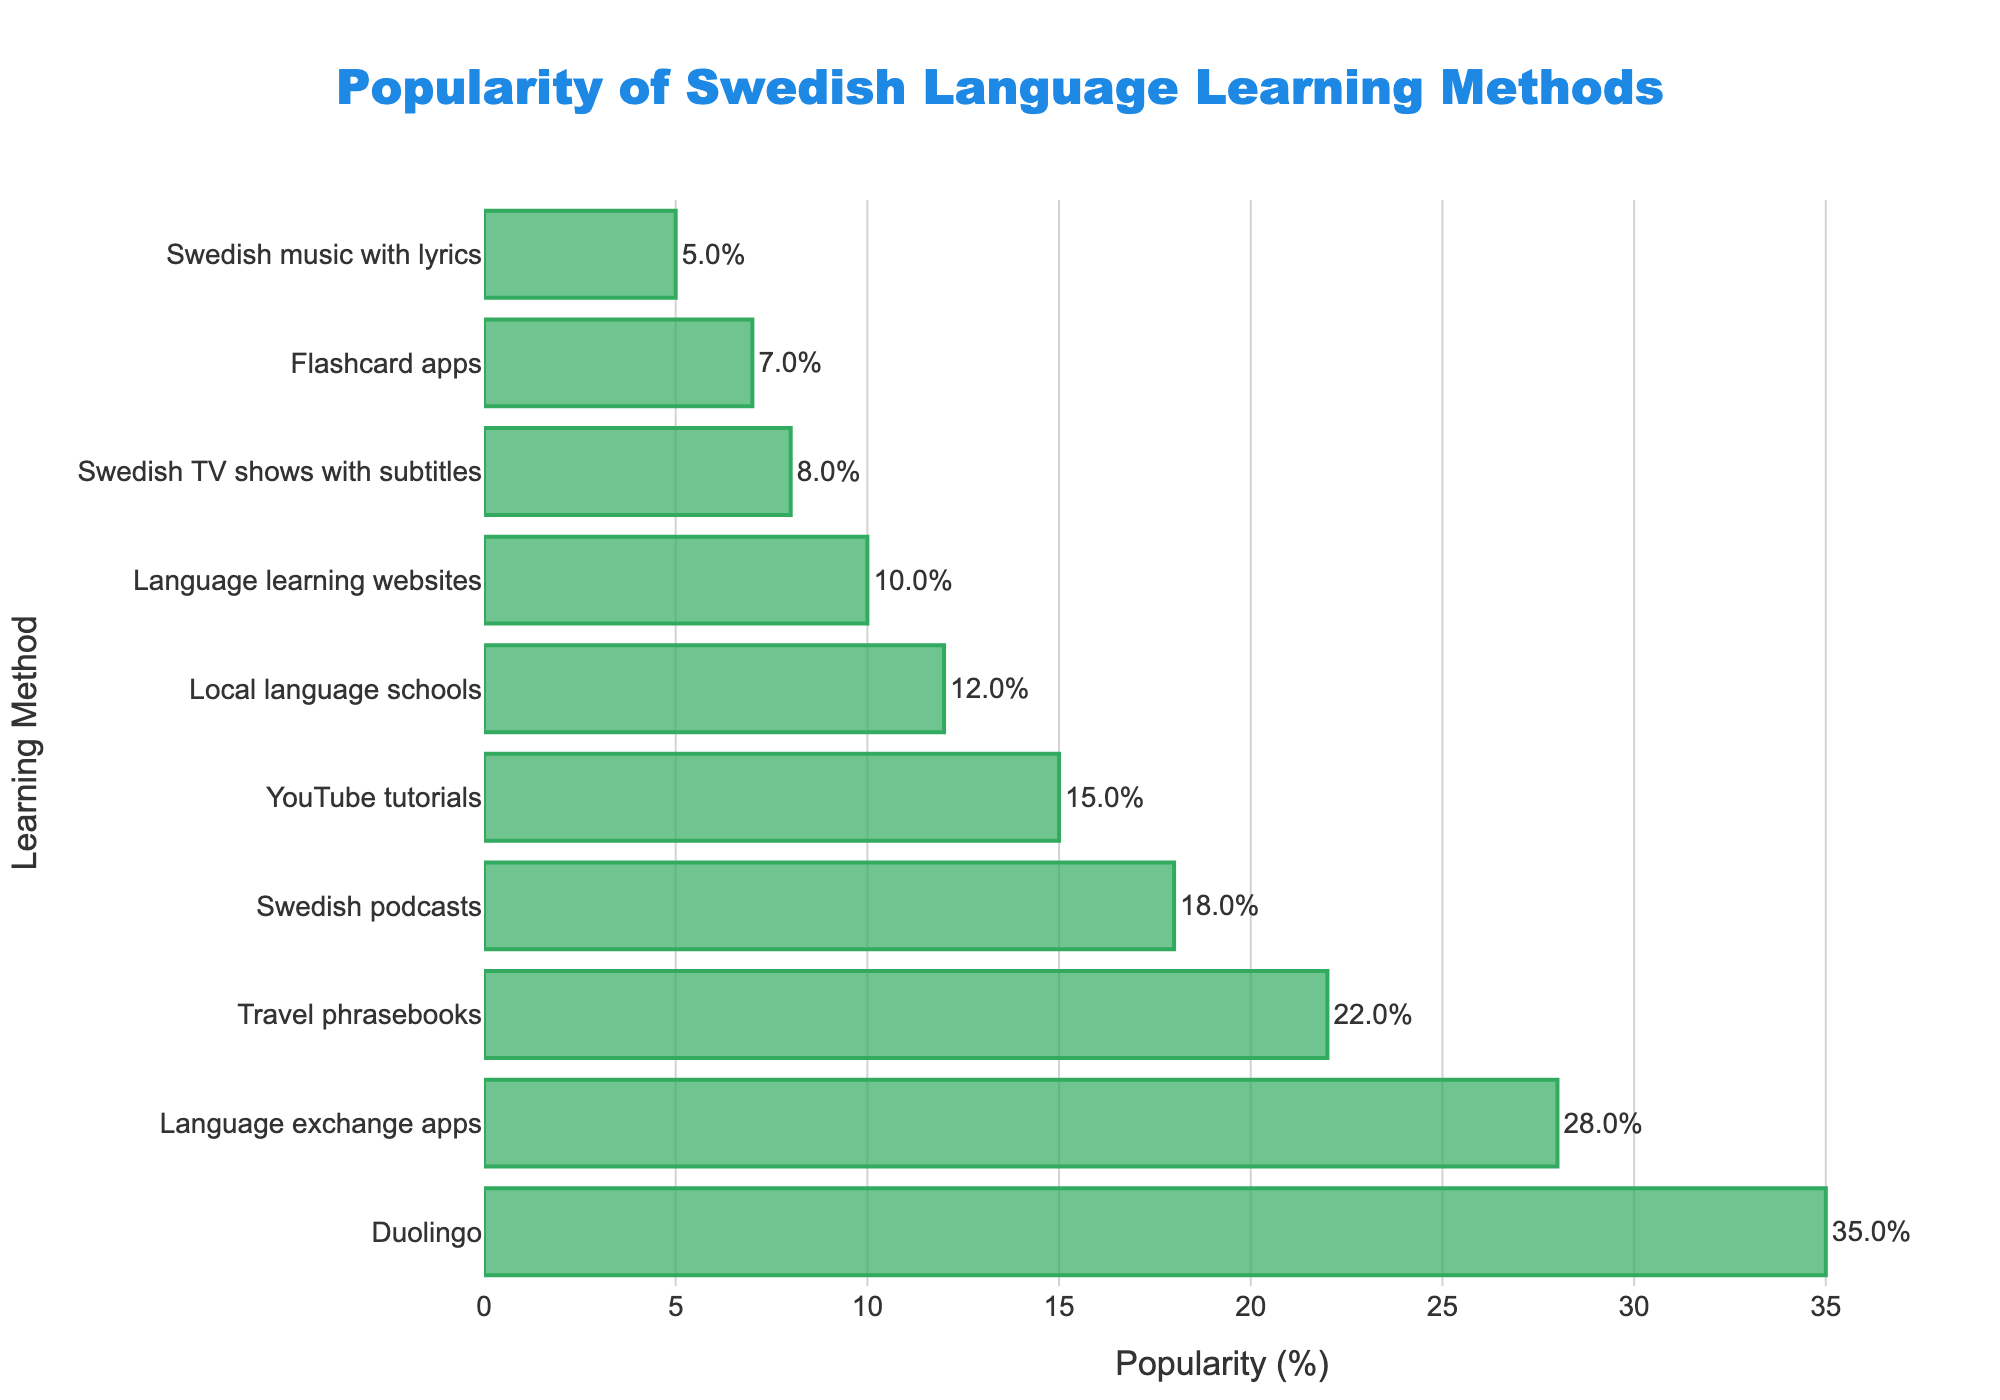Which learning method is the most popular? The method with the highest bar represents the most popular method. According to the figure, the method "Duolingo" has the tallest bar, i.e., the highest popularity percentage.
Answer: Duolingo Which learning method is the least popular? The method with the shortest bar represents the least popular method. According to the figure, the method "Swedish music with lyrics" has the shortest bar, i.e., the lowest popularity percentage.
Answer: Swedish music with lyrics What is the total popularity percentage of the top three methods? Add the popularity percentages of the top three methods. These are Duolingo (35%), Language exchange apps (28%), and Travel phrasebooks (22%). The total is 35% + 28% + 22% = 85%.
Answer: 85% How much more popular are language exchange apps compared to local language schools? Subtract the popularity percentage of local language schools from that of language exchange apps. Language exchange apps have a popularity of 28%, while local language schools have 12%. The difference is 28% - 12% = 16%.
Answer: 16% Which methods have a popularity percentage greater than 20%? Identify the methods with bars extending beyond the 20% mark on the x-axis. According to the figure, the methods are Duolingo (35%), Language exchange apps (28%), and Travel phrasebooks (22%).
Answer: Duolingo, Language exchange apps, Travel phrasebooks What is the combined popularity percentage of methods that use digital platforms (including Duolingo, Language exchange apps, Flashcard apps, and Language learning websites)? Sum the popularity percentages of Duolingo (35%), Language exchange apps (28%), Flashcard apps (7%), and Language learning websites (10%). The total is 35% + 28% + 7% + 10% = 80%.
Answer: 80% Are Swedish podcasts more or less popular than YouTube tutorials? Compare the lengths of the bars for Swedish podcasts and YouTube tutorials. Swedish podcasts have a popularity of 18%, while YouTube tutorials have 15%, making podcasts more popular.
Answer: More Between travel phrasebooks and Swedish TV shows with subtitles, which method has a higher popularity percentage? Compare the lengths of the bars for travel phrasebooks and Swedish TV shows with subtitles. Travel phrasebooks have a popularity of 22%, while Swedish TV shows with subtitles have 8%, making phrasebooks more popular.
Answer: Travel phrasebooks 